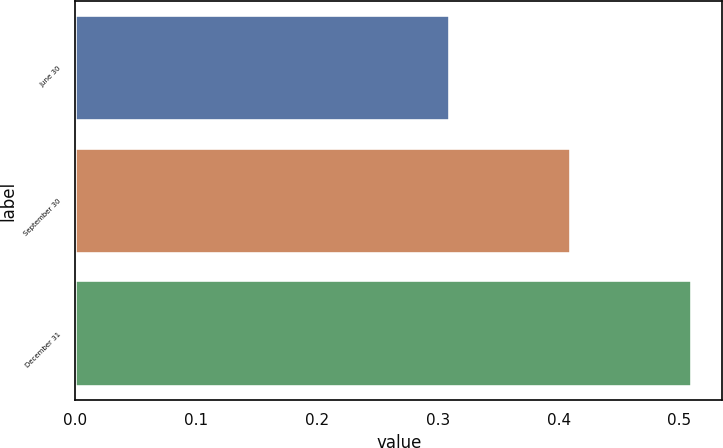Convert chart. <chart><loc_0><loc_0><loc_500><loc_500><bar_chart><fcel>June 30<fcel>September 30<fcel>December 31<nl><fcel>0.31<fcel>0.41<fcel>0.51<nl></chart> 